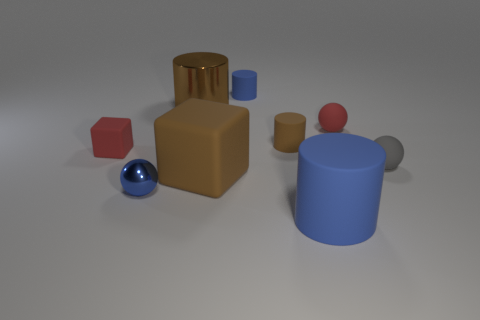Is there any other thing that is the same shape as the tiny gray rubber object?
Make the answer very short. Yes. Is the large metallic thing the same shape as the gray thing?
Offer a terse response. No. Is there anything else that has the same material as the tiny red ball?
Your answer should be compact. Yes. The red rubber cube has what size?
Offer a very short reply. Small. There is a tiny sphere that is in front of the tiny red block and on the right side of the big metal object; what color is it?
Your response must be concise. Gray. Are there more tiny blue matte cylinders than blue objects?
Give a very brief answer. No. What number of things are green things or big cylinders that are behind the small blue ball?
Ensure brevity in your answer.  1. Do the blue metallic thing and the red rubber block have the same size?
Offer a very short reply. Yes. Are there any big blue objects behind the tiny red block?
Give a very brief answer. No. There is a blue thing that is on the right side of the brown metal cylinder and in front of the tiny brown cylinder; what size is it?
Make the answer very short. Large. 